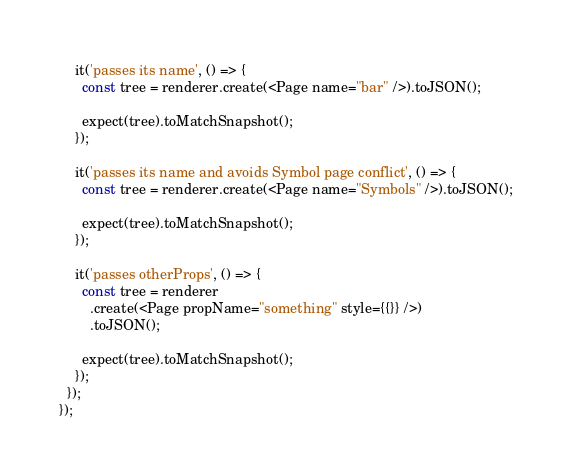Convert code to text. <code><loc_0><loc_0><loc_500><loc_500><_JavaScript_>    it('passes its name', () => {
      const tree = renderer.create(<Page name="bar" />).toJSON();

      expect(tree).toMatchSnapshot();
    });

    it('passes its name and avoids Symbol page conflict', () => {
      const tree = renderer.create(<Page name="Symbols" />).toJSON();

      expect(tree).toMatchSnapshot();
    });

    it('passes otherProps', () => {
      const tree = renderer
        .create(<Page propName="something" style={{}} />)
        .toJSON();

      expect(tree).toMatchSnapshot();
    });
  });
});
</code> 